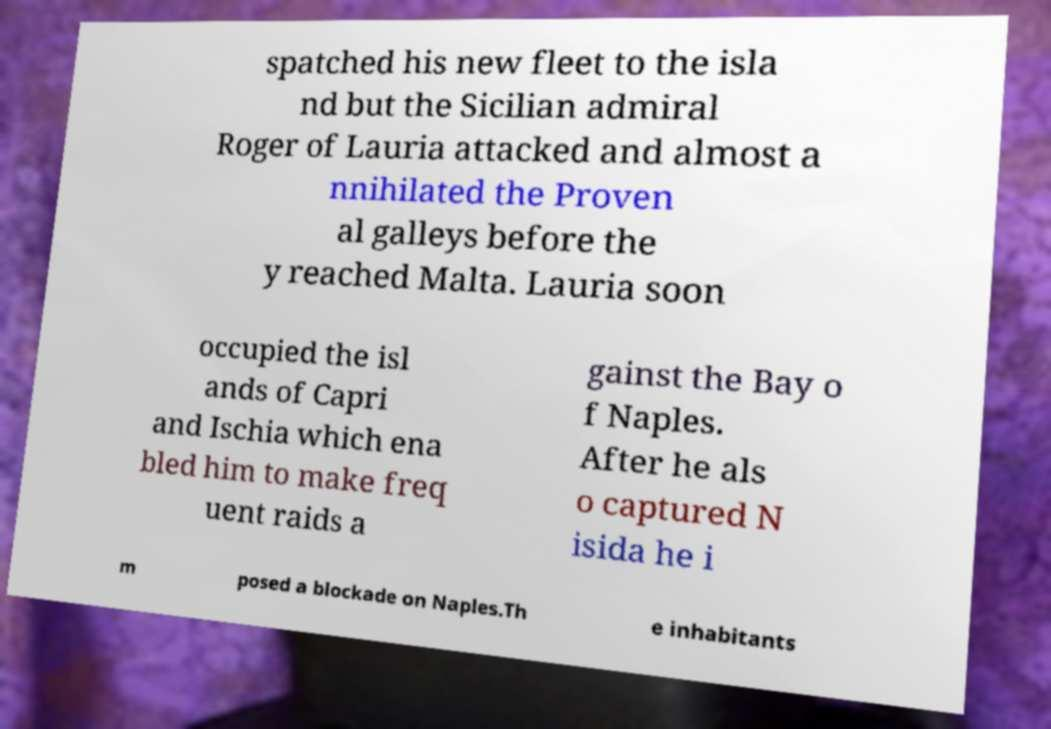Could you extract and type out the text from this image? spatched his new fleet to the isla nd but the Sicilian admiral Roger of Lauria attacked and almost a nnihilated the Proven al galleys before the y reached Malta. Lauria soon occupied the isl ands of Capri and Ischia which ena bled him to make freq uent raids a gainst the Bay o f Naples. After he als o captured N isida he i m posed a blockade on Naples.Th e inhabitants 